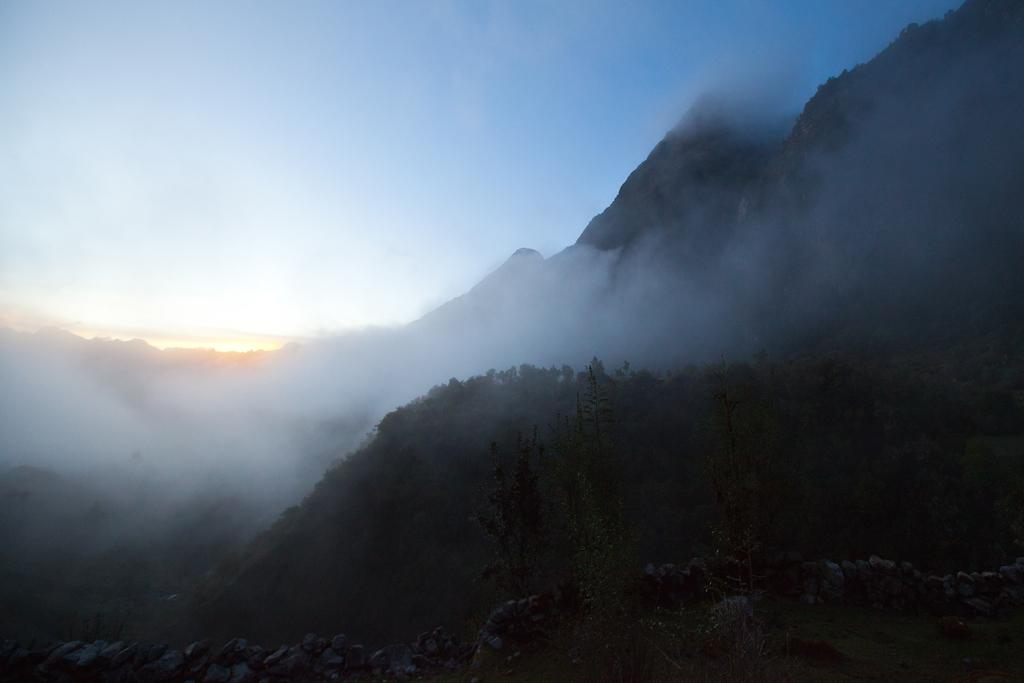What type of natural formation can be seen in the image? There are mountains in the image. What other elements are present in the image? There are plants, the ground, stones, and the sky visible in the image. What is the weather condition like in the image? There is fog in the image, which suggests a cool or damp environment. What type of vein is visible in the image? There is no vein present in the image; it features mountains, plants, the ground, stones, and fog. 